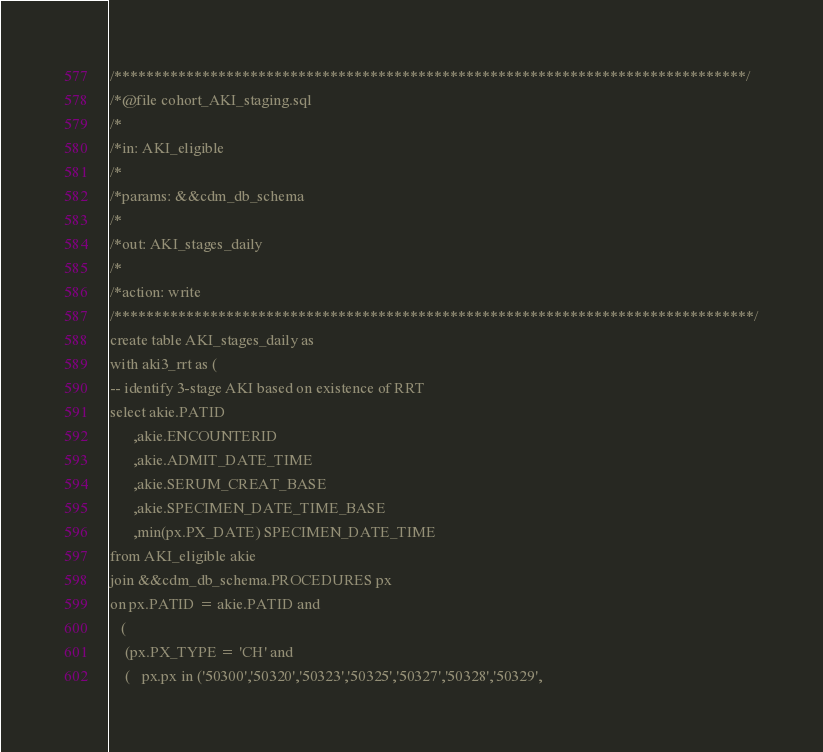<code> <loc_0><loc_0><loc_500><loc_500><_SQL_>/*******************************************************************************/
/*@file cohort_AKI_staging.sql
/*
/*in: AKI_eligible
/*
/*params: &&cdm_db_schema
/*   
/*out: AKI_stages_daily
/*
/*action: write
/********************************************************************************/
create table AKI_stages_daily as
with aki3_rrt as (
-- identify 3-stage AKI based on existence of RRT
select akie.PATID
      ,akie.ENCOUNTERID
      ,akie.ADMIT_DATE_TIME
      ,akie.SERUM_CREAT_BASE
      ,akie.SPECIMEN_DATE_TIME_BASE
      ,min(px.PX_DATE) SPECIMEN_DATE_TIME
from AKI_eligible akie
join &&cdm_db_schema.PROCEDURES px
on px.PATID = akie.PATID and
   (
    (px.PX_TYPE = 'CH' and 
    (   px.px in ('50300','50320','50323','50325','50327','50328','50329',</code> 